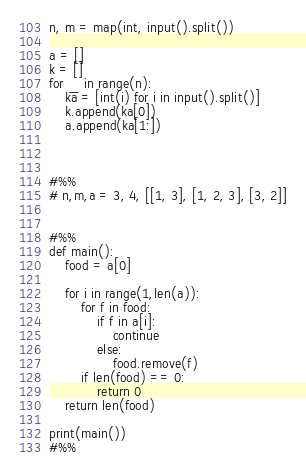<code> <loc_0><loc_0><loc_500><loc_500><_Python_>

n, m = map(int, input().split())

a = []
k = []
for _ in range(n):
    ka = [int(i) for i in input().split()]
    k.append(ka[0])
    a.append(ka[1:])



#%%
# n,m,a = 3, 4, [[1, 3], [1, 2, 3], [3, 2]]


#%%
def main():
    food = a[0]

    for i in range(1,len(a)):
        for f in food:
            if f in a[i]:
                continue
            else:
                food.remove(f)
        if len(food) == 0:
            return 0
    return len(food)

print(main())    
#%%
</code> 